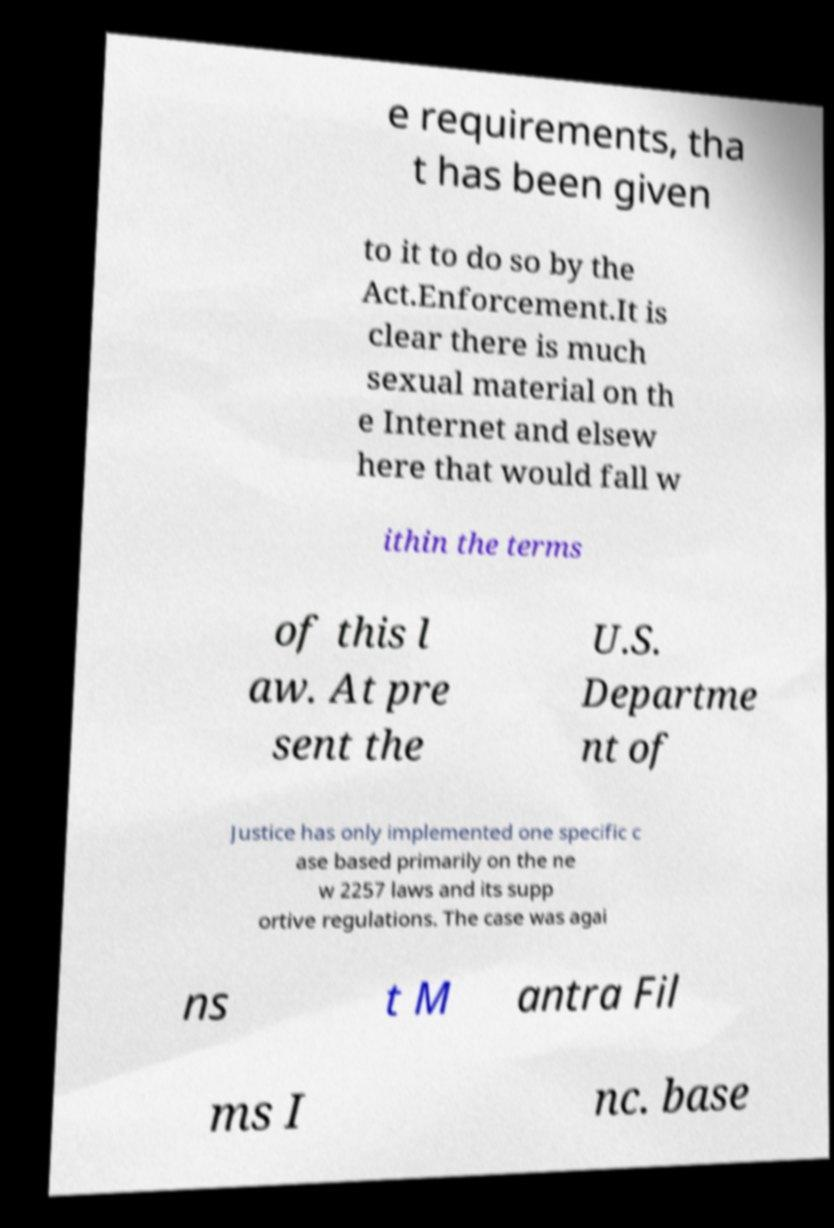What messages or text are displayed in this image? I need them in a readable, typed format. e requirements, tha t has been given to it to do so by the Act.Enforcement.It is clear there is much sexual material on th e Internet and elsew here that would fall w ithin the terms of this l aw. At pre sent the U.S. Departme nt of Justice has only implemented one specific c ase based primarily on the ne w 2257 laws and its supp ortive regulations. The case was agai ns t M antra Fil ms I nc. base 